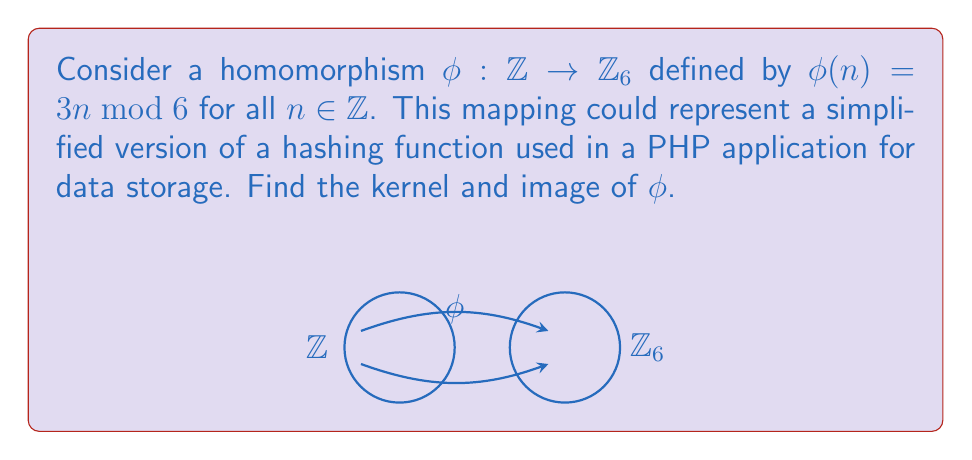Can you solve this math problem? To find the kernel and image of $\phi$, let's follow these steps:

1) Kernel:
   The kernel of $\phi$ is the set of all elements in $\mathbb{Z}$ that map to the identity element in $\mathbb{Z}_6$ (which is 0).
   
   $\text{ker}(\phi) = \{n \in \mathbb{Z} : \phi(n) = 0\}$
   
   $3n \equiv 0 \pmod{6}$
   $n \equiv 0 \pmod{2}$
   
   Therefore, $\text{ker}(\phi) = \{2k : k \in \mathbb{Z}\}$, which is the set of all even integers.

2) Image:
   The image of $\phi$ is the set of all elements in $\mathbb{Z}_6$ that are outputs of $\phi$.
   
   $\text{im}(\phi) = \{\phi(n) : n \in \mathbb{Z}\}$
   
   Let's calculate $\phi(n)$ for $n = 0, 1, 2, 3, 4, 5$:
   
   $\phi(0) = 0$
   $\phi(1) = 3$
   $\phi(2) = 0$
   $\phi(3) = 3$
   $\phi(4) = 0$
   $\phi(5) = 3$
   
   We see that the only possible outputs are 0 and 3.
   
   Therefore, $\text{im}(\phi) = \{0, 3\}$

3) Verification:
   We can verify that $|\text{ker}(\phi)| \cdot |\text{im}(\phi)| = |\mathbb{Z}|$:
   $\infty \cdot 2 = \infty$, which holds true.

This homomorphism effectively creates a simple hash function that maps integers to either 0 or 3 in $\mathbb{Z}_6$, which could be used for basic data categorization in a PHP application.
Answer: $\text{ker}(\phi) = \{2k : k \in \mathbb{Z}\}$, $\text{im}(\phi) = \{0, 3\}$ 